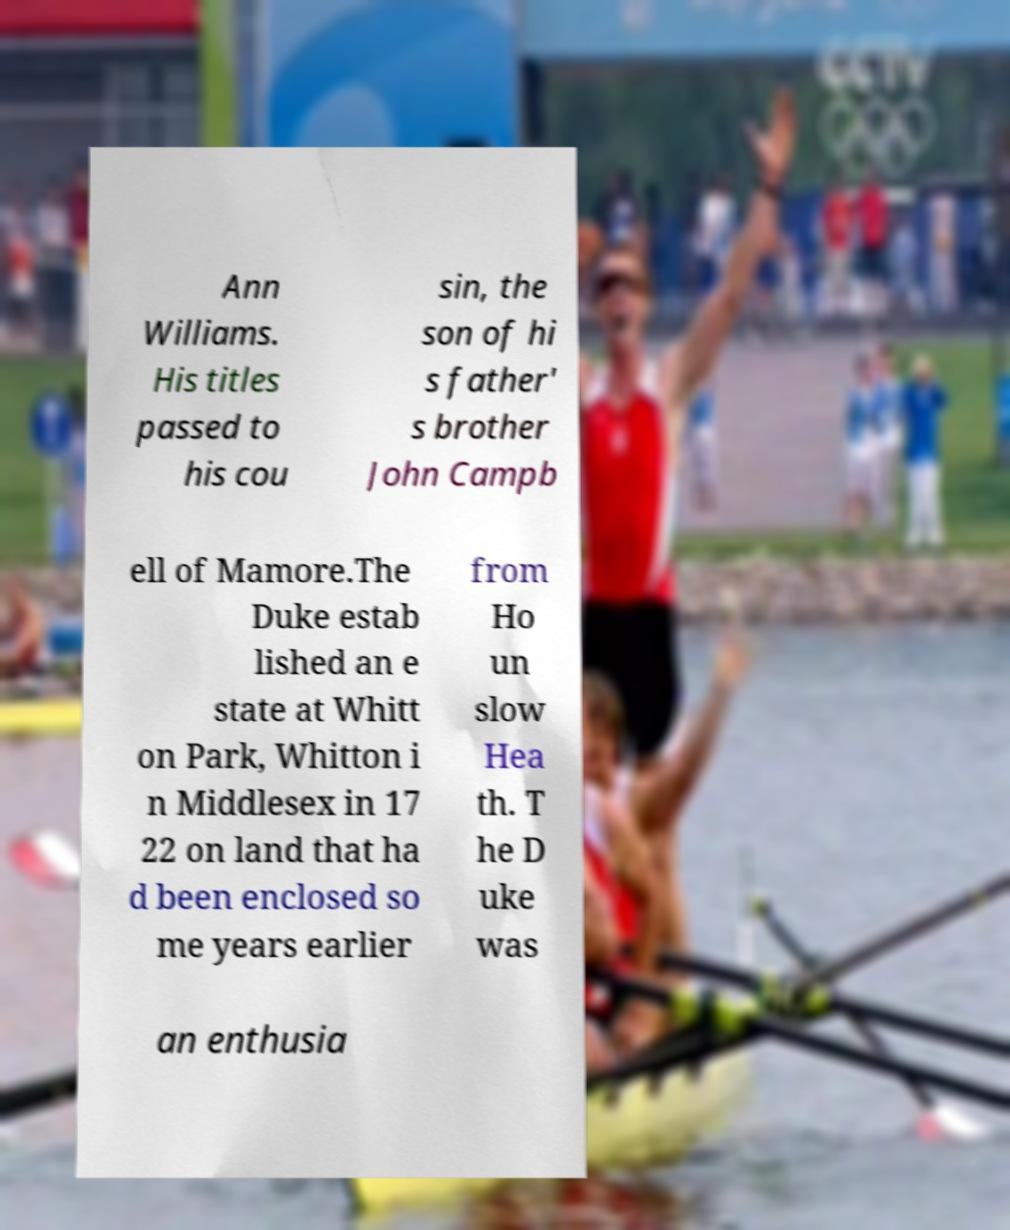Please read and relay the text visible in this image. What does it say? Ann Williams. His titles passed to his cou sin, the son of hi s father' s brother John Campb ell of Mamore.The Duke estab lished an e state at Whitt on Park, Whitton i n Middlesex in 17 22 on land that ha d been enclosed so me years earlier from Ho un slow Hea th. T he D uke was an enthusia 